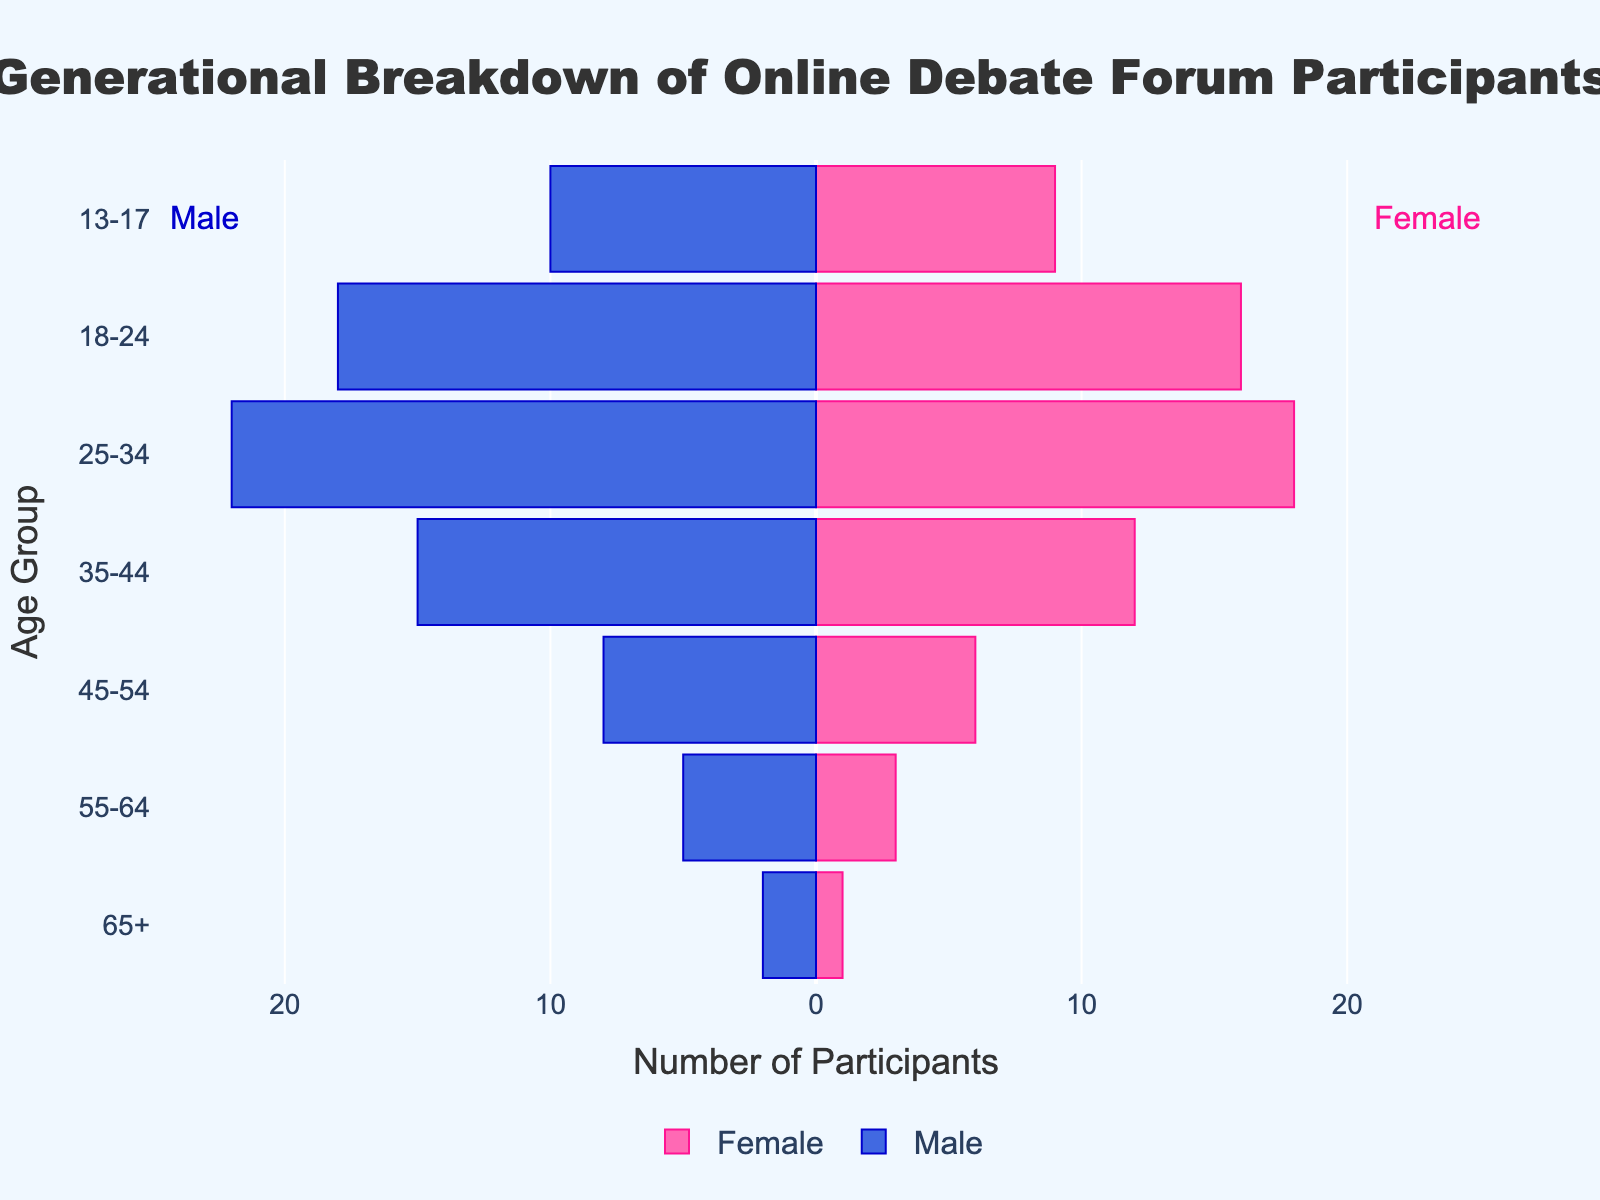which age group has the most female participants? The figure shows bars representing the number of male and female participants across different age groups. To determine which age group has the most female participants, observe the length of the pink bars and identify the longest one. The 25-34 age group has the longest pink bar.
Answer: 25-34 what is the total number of participants in the 35-44 age group? To find the total number of participants in the 35-44 age group, sum the values represented by the bars for males and females. The figure indicates there are 15 male and 12 female participants in this age group.
Answer: 27 how many more female participants are there in the 18-24 age group compared to the 13-17 age group? To find the difference, look at the female participants in the 18-24 and 13-17 age groups. The figure shows 16 female participants in the 18-24 group and 9 in the 13-17 group. Subtracting these gives you 16 - 9.
Answer: 7 which gender has more participants in the 45-54 age group? To compare, look at the bars for males and females in the 45-54 age group. The figure shows 8 male participants and 6 female participants in this age group. Therefore, the male count is higher.
Answer: Male how does the number of male participants in the 25-34 age group compare to the number in the 35-44 age group? To compare, observe the lengths of the blue bars for the 25-34 and 35-44 age groups. The figure indicates 22 males in the 25-34 group and 15 in the 35-44 group.
Answer: More in 25-34 what is the difference in total participants between the youngest (13-17) and the oldest (65+) age groups? Add the number of males and females in the 13-17 and 65+ age groups. The 13-17 group has 10 males and 9 females (total 19), while 65+ has 2 males and 1 female (total 3). Subtracting these totals: 19 - 3.
Answer: 16 which age group has the smallest gap between male and female participants? To find the smallest gender gap, calculate the absolute differences between the number of male and female participants across age groups. The difference is smallest for the 13-17 age group, where females (9) and males (10) differ by 1.
Answer: 13-17 how many age groups have more male participants than female participants? Count the age groups where the blue bar (males) is longer than the pink bar (females). From the figure, the 55-64, 45-54, 35-44, 25-34, and 13-17 age groups show more males than females.
Answer: 5 